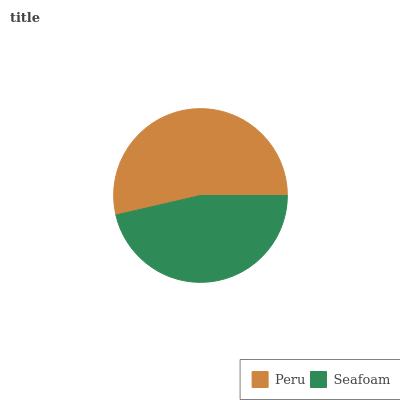Is Seafoam the minimum?
Answer yes or no. Yes. Is Peru the maximum?
Answer yes or no. Yes. Is Seafoam the maximum?
Answer yes or no. No. Is Peru greater than Seafoam?
Answer yes or no. Yes. Is Seafoam less than Peru?
Answer yes or no. Yes. Is Seafoam greater than Peru?
Answer yes or no. No. Is Peru less than Seafoam?
Answer yes or no. No. Is Peru the high median?
Answer yes or no. Yes. Is Seafoam the low median?
Answer yes or no. Yes. Is Seafoam the high median?
Answer yes or no. No. Is Peru the low median?
Answer yes or no. No. 